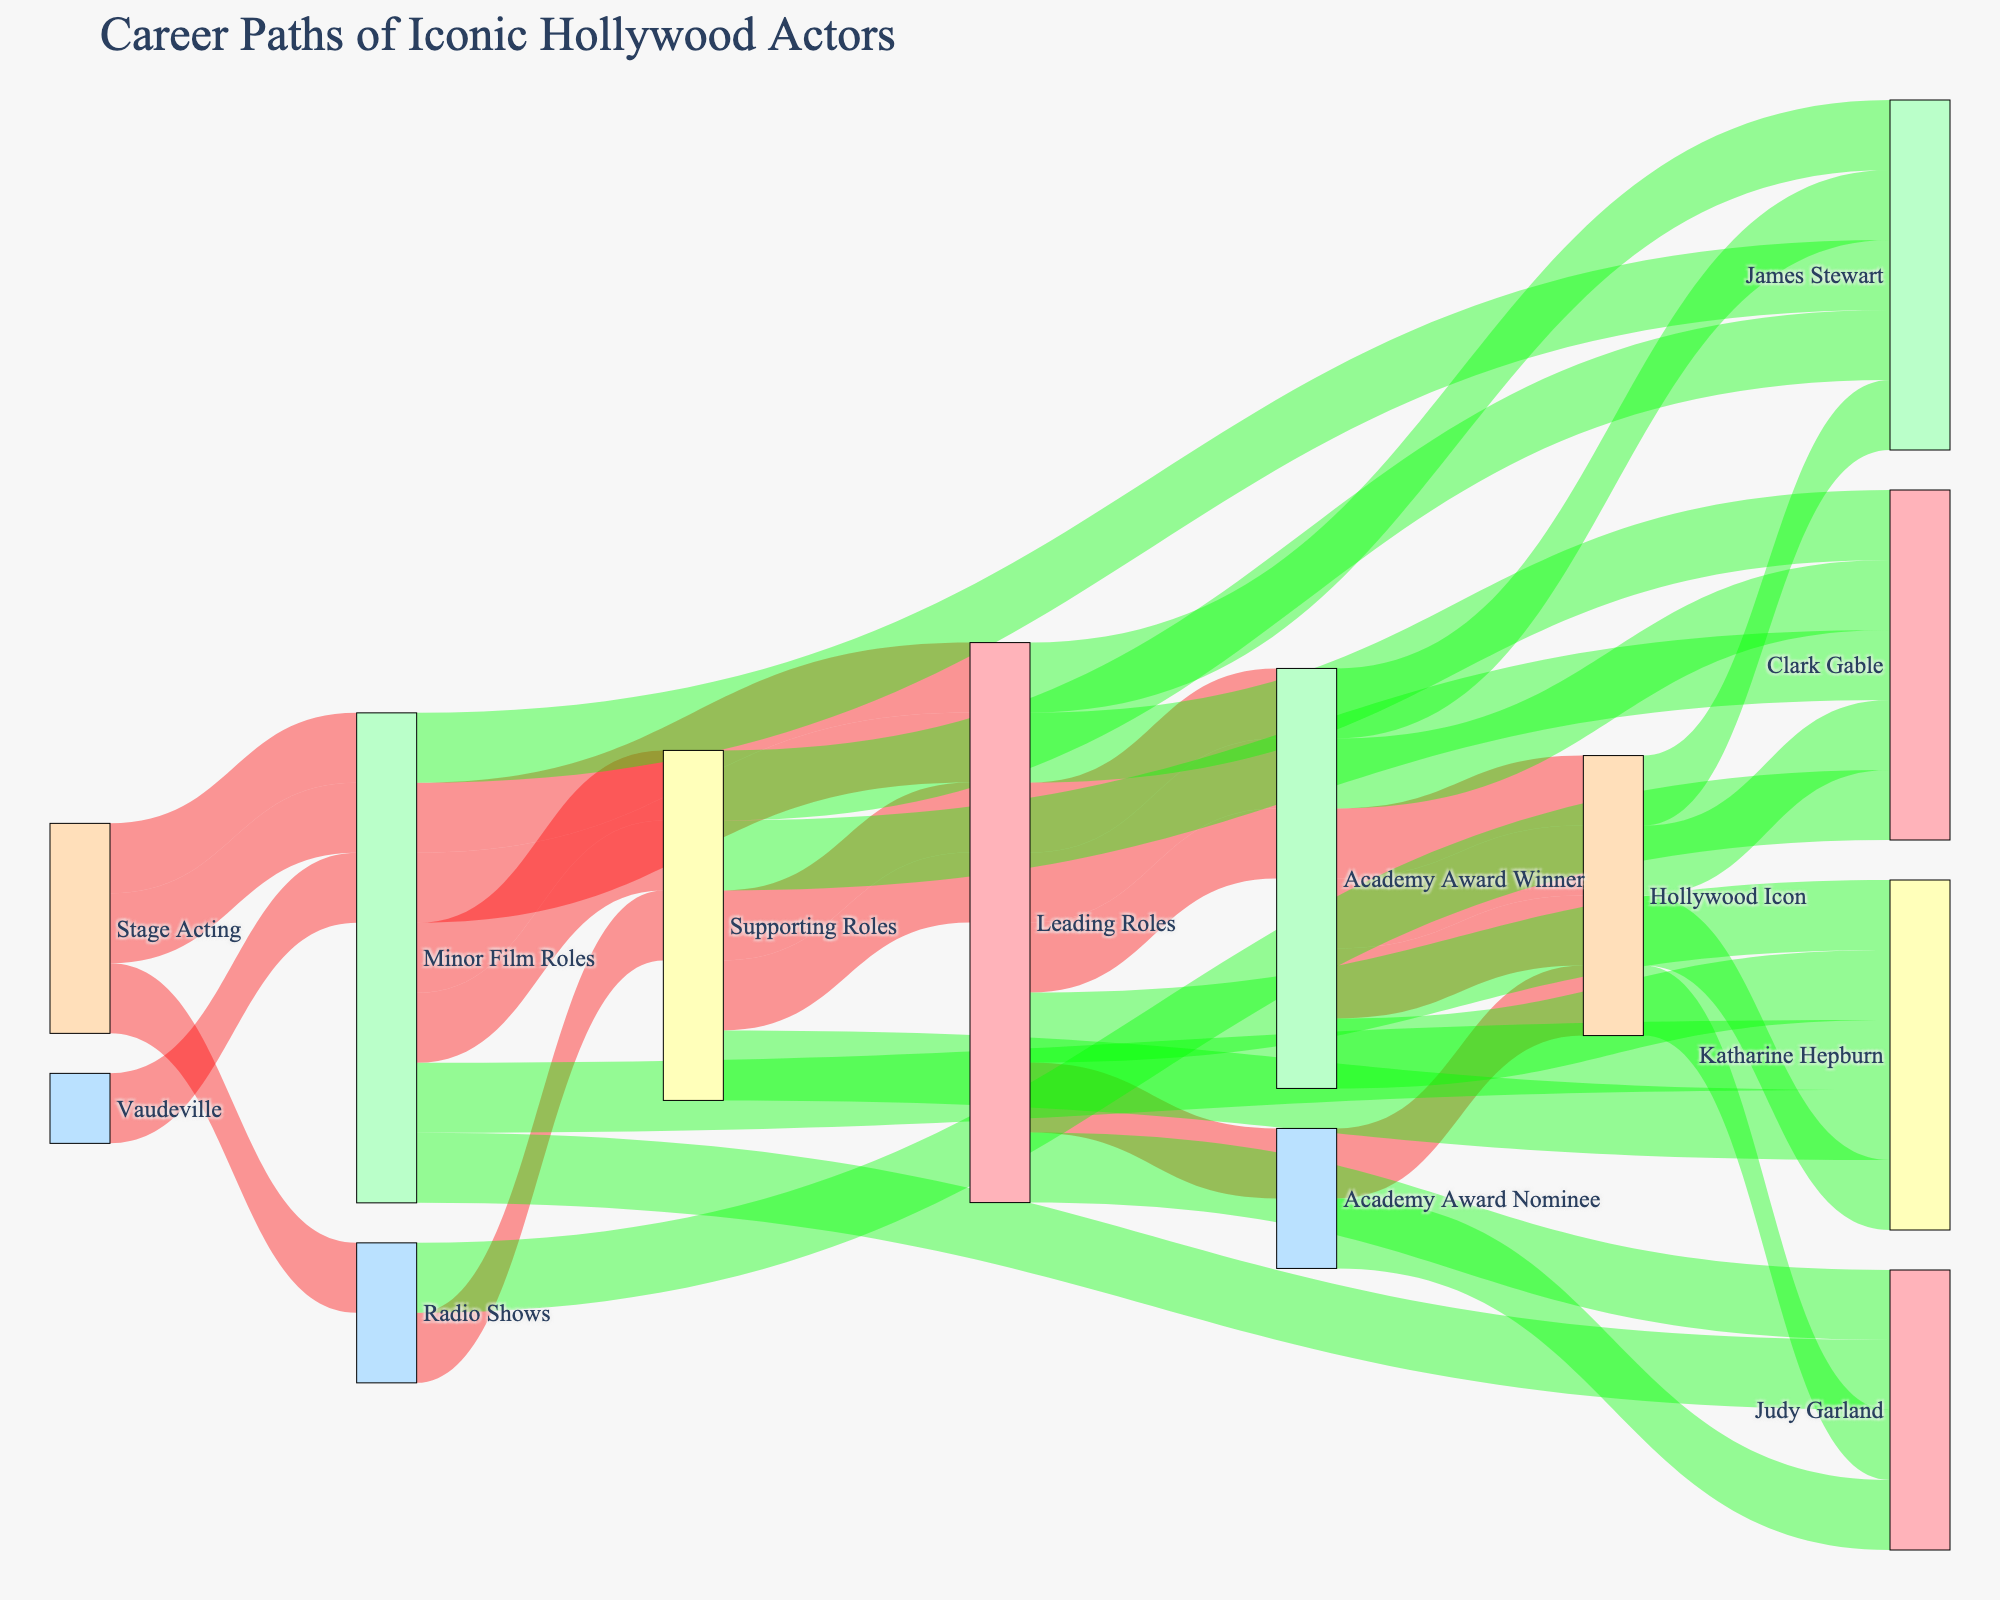What is the title of the diagram? The title is usually displayed at the top of the diagram to describe what it represents. Here, it's clearly stated above the Sankey Diagram.
Answer: Career Paths of Iconic Hollywood Actors How many actors ultimately became Hollywood Icons according to the diagram? Look for the number of nodes labeled "Hollywood Icon" and identify how many unique paths lead to it.
Answer: Four Who transitioned from radio shows to supporting roles and eventually became Hollywood Icons? First, identify the actors who started with radio shows and moved to supporting roles. Then, follow those paths to see if they lead to Hollywood Icons.
Answer: Clark Gable Which actor(s) progressed from Vaudeville to Leading Roles? Trace the paths starting from Vaudeville to check if any of them go directly or indirectly to Leading Roles.
Answer: Judy Garland What is the common intermediate career step for both Katharine Hepburn and James Stewart before they became Academy Award Winners? Look at the intermediate roles for both actors and see the steps before they reached the Academy Award Winner stage.
Answer: Leading Roles Which sources eventually lead to becoming a Hollywood Icon for any of the actors? Track all initial career sources that connect, directly or indirectly, to the Hollywood Icon nodes.
Answer: Stage Acting, Vaudeville, Minor Film Roles, Radio Shows Compare the career paths of Clark Gable and Judy Garland. What are the key differences? Analyze the Sankey diagram to observe the paths both actors took. Compare the stages and intermediate steps between their paths.
Answer: Gable: Radio Shows → Supporting Roles → Leading Roles → Academy Award Winner; Garland: Vaudeville → Minor Film Roles → Leading Roles → Academy Award Nominee How many total unique career paths are shown in the diagram? Count the number of distinct paths from the Source nodes all the way to the Destination nodes. A path includes each unique set of nodes it passes through.
Answer: Seven From which starting career did the most paths originate? Identify the starting nodes and count the outgoing paths from each. The node with the highest number of paths is the answer.
Answer: Stage Acting What color represents the first set of career steps in the diagram? Look at the links between nodes and identify the color for the initial connections from the Source nodes to the Intermediate nodes.
Answer: Red 